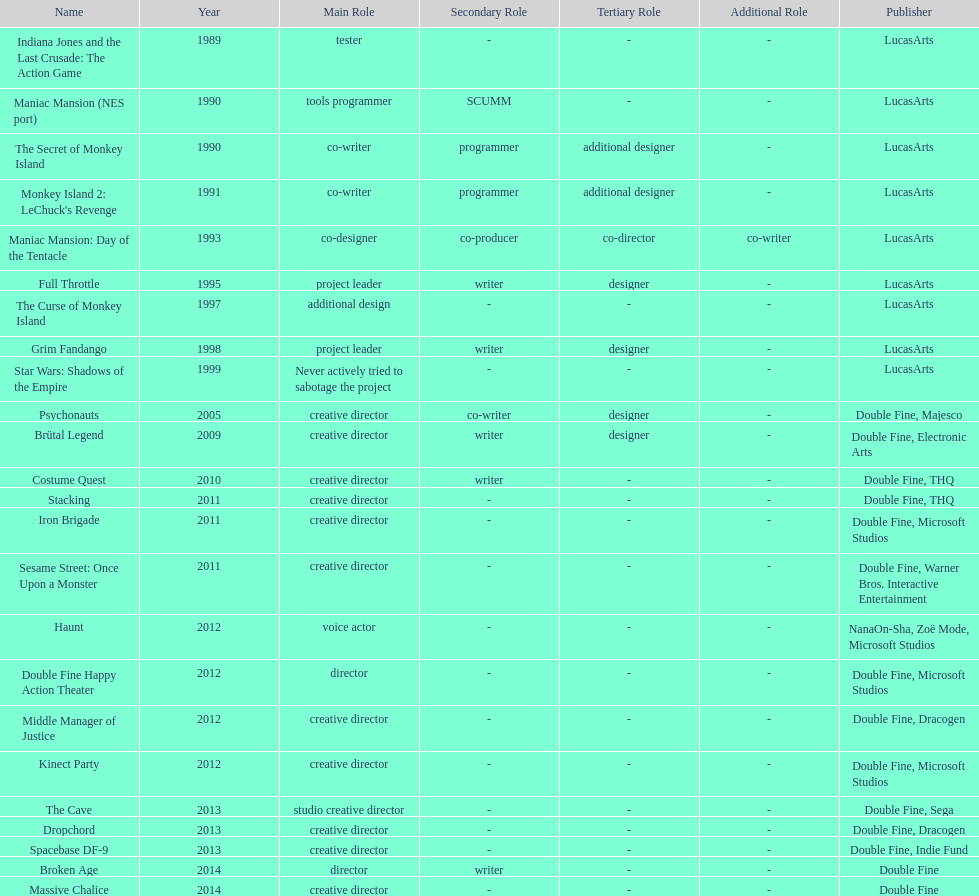Which game is credited with a creative director and warner bros. interactive entertainment as their creative director? Sesame Street: Once Upon a Monster. 